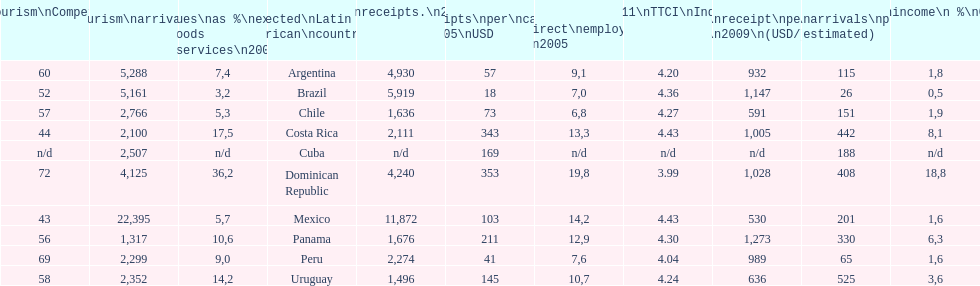How many international tourism arrivals in 2010(x1000) did mexico have? 22,395. 